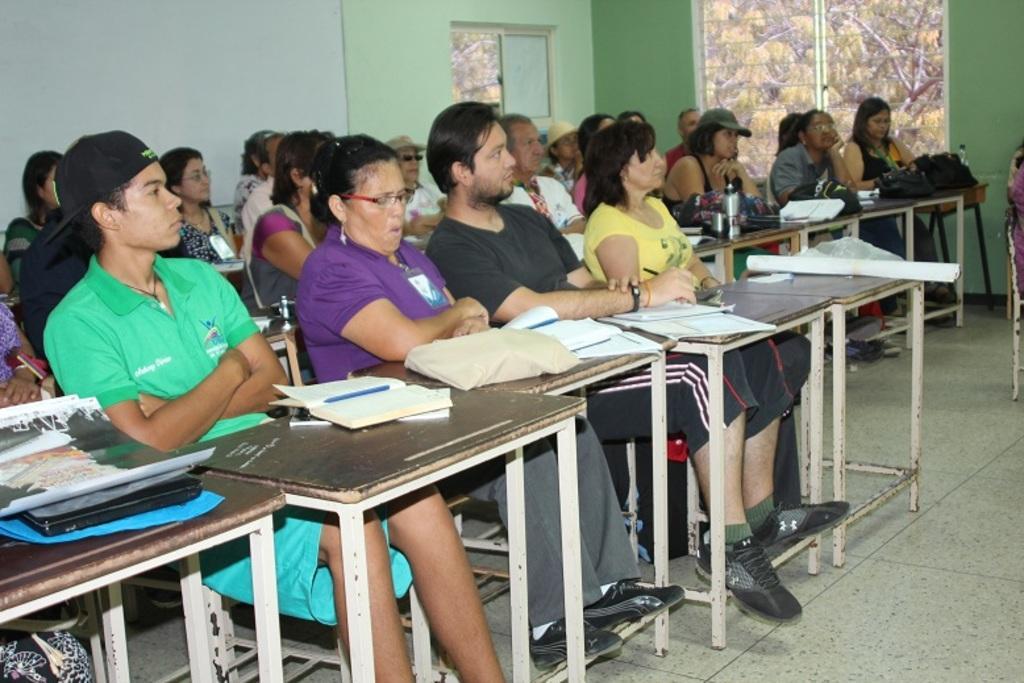Describe this image in one or two sentences. This is a picture taken in a class room, there are group of people who are sitting on a chairs. In front of them there is a tables, on the tables there is a book, pen, bottle and bags. Background of this people is a wall which is in green color. 